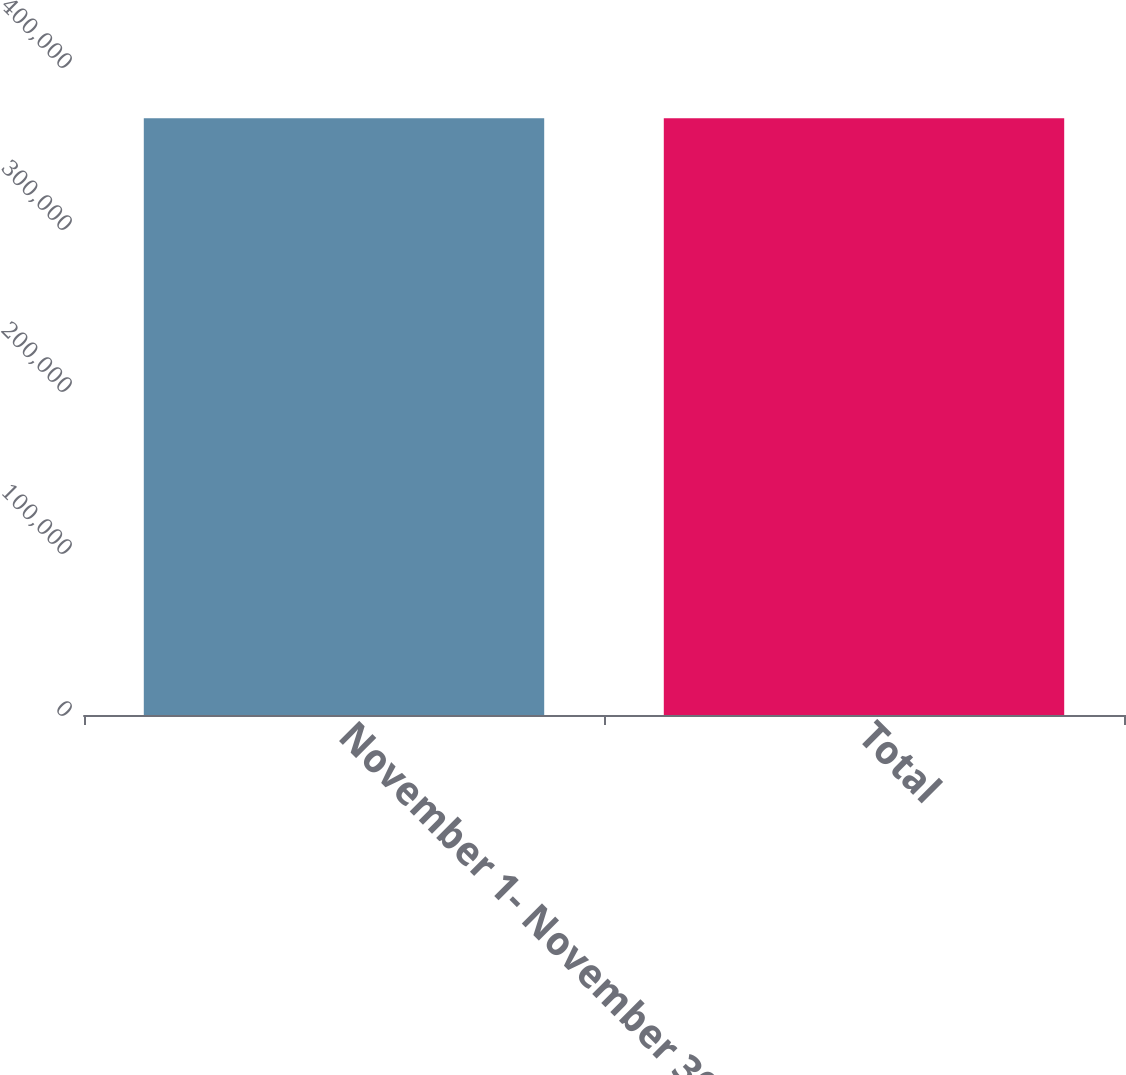Convert chart to OTSL. <chart><loc_0><loc_0><loc_500><loc_500><bar_chart><fcel>November 1- November 30 2008<fcel>Total<nl><fcel>368406<fcel>368406<nl></chart> 